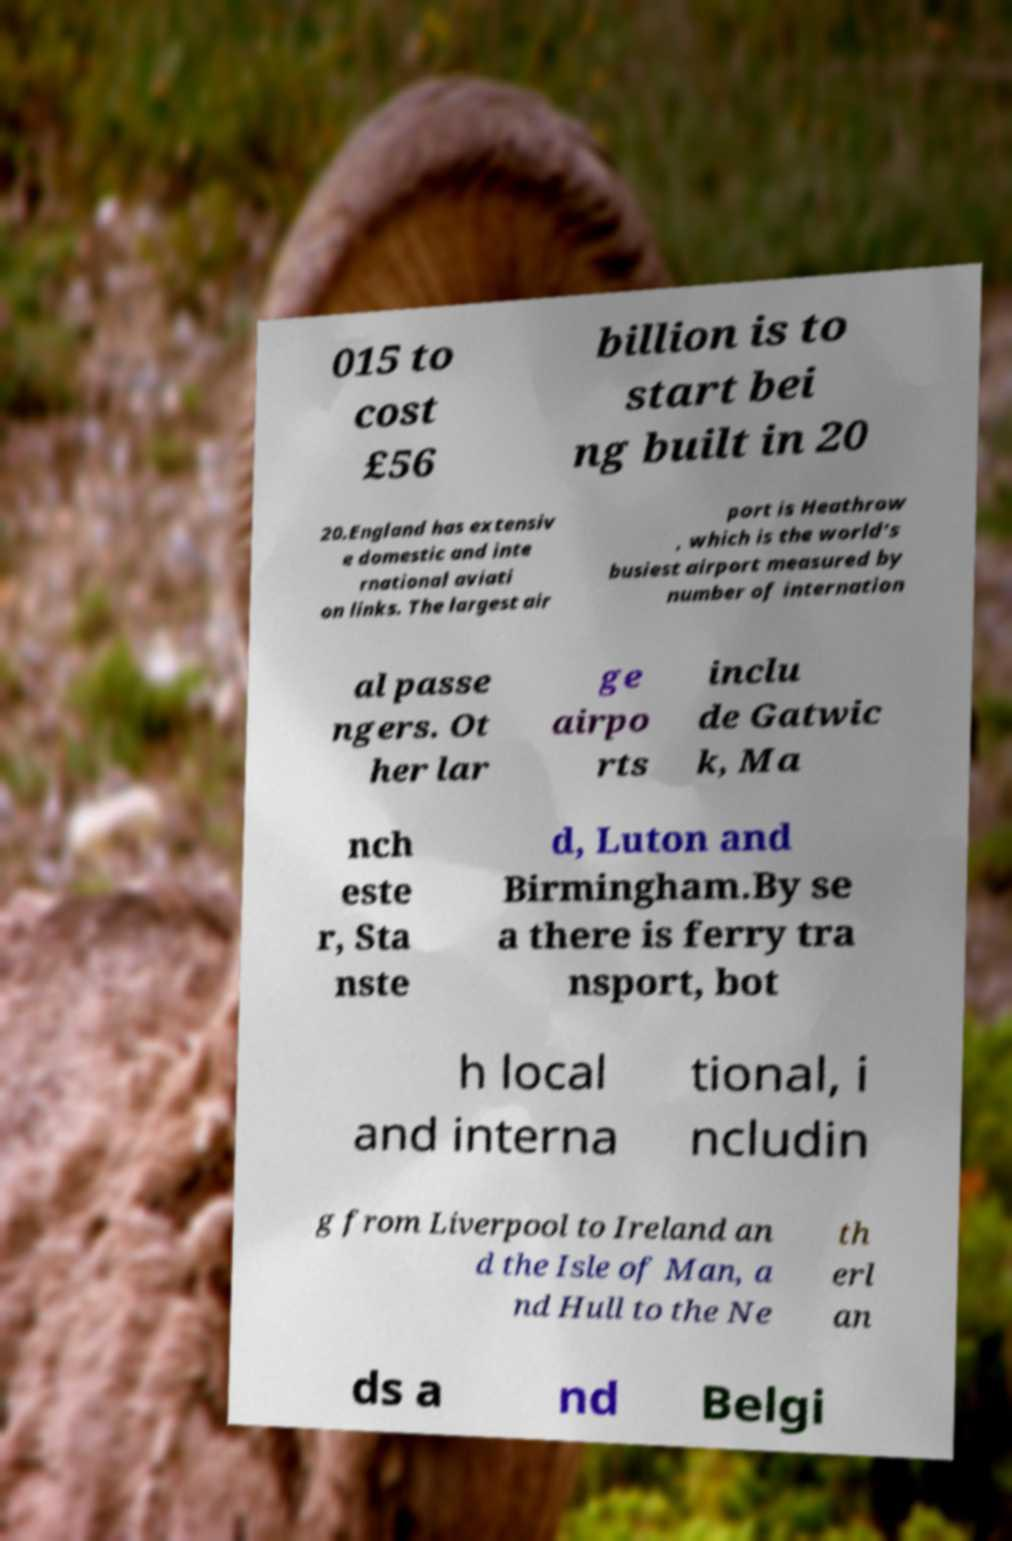Please identify and transcribe the text found in this image. 015 to cost £56 billion is to start bei ng built in 20 20.England has extensiv e domestic and inte rnational aviati on links. The largest air port is Heathrow , which is the world's busiest airport measured by number of internation al passe ngers. Ot her lar ge airpo rts inclu de Gatwic k, Ma nch este r, Sta nste d, Luton and Birmingham.By se a there is ferry tra nsport, bot h local and interna tional, i ncludin g from Liverpool to Ireland an d the Isle of Man, a nd Hull to the Ne th erl an ds a nd Belgi 